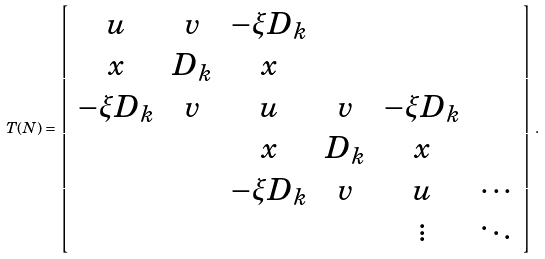Convert formula to latex. <formula><loc_0><loc_0><loc_500><loc_500>T ( N ) = \left [ \begin{array} { c c c c c c } u & v & - \xi D _ { k } \\ x & D _ { k } & x \\ - \xi D _ { k } & v & u & v & - \xi D _ { k } \\ & & x & D _ { k } & x \\ & & - \xi D _ { k } & v & u & \cdots \\ & & & & \vdots & \ddots \end{array} \right ] \, .</formula> 